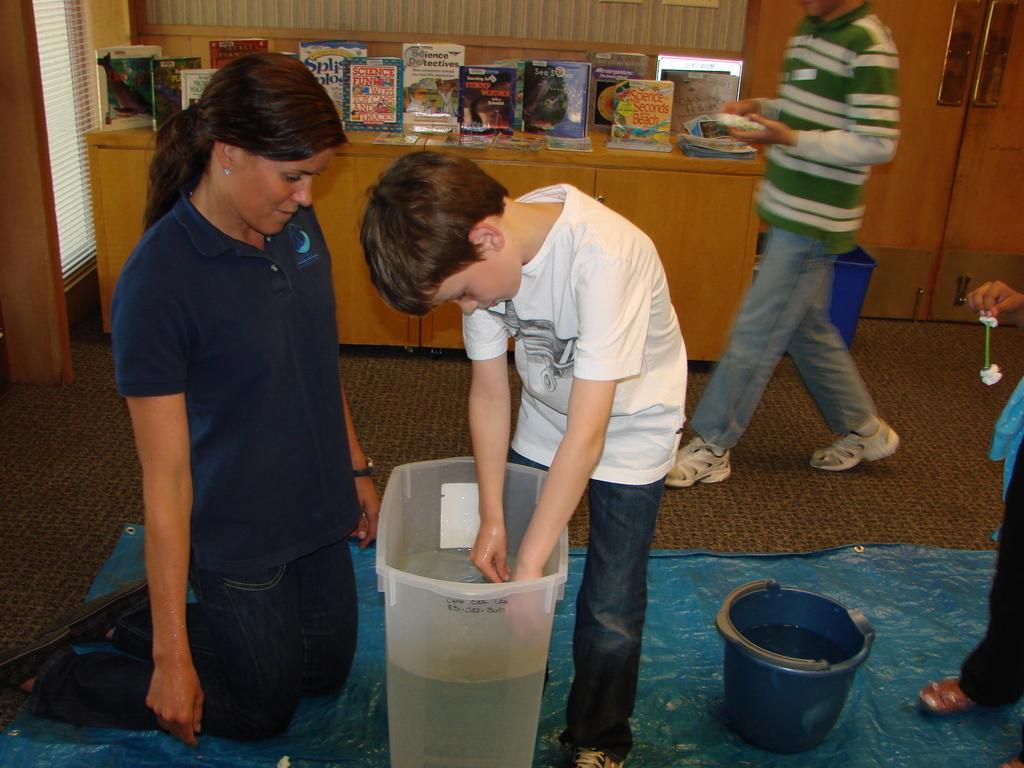Please provide a concise description of this image. In this image we can see two persons and plastic containers with water. At the bottom of the image there is a plastic sheet. In the background of the image there are bookshelves, a person and other objects. On the right side of the image it looks like a person. 